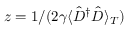<formula> <loc_0><loc_0><loc_500><loc_500>z = 1 / ( 2 \gamma \langle \hat { D } ^ { \dagger } \hat { D } \rangle _ { T } )</formula> 